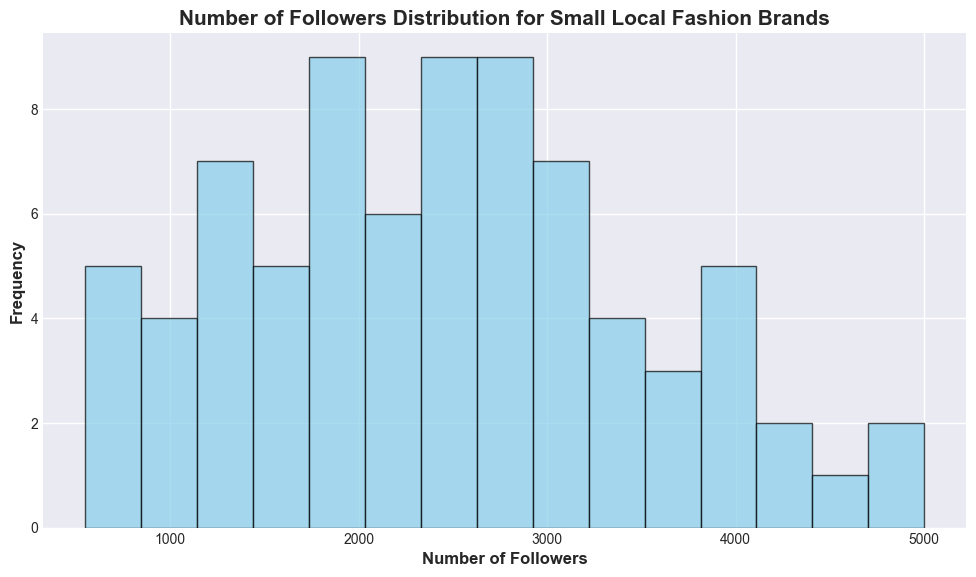What is the most common range of followers? Observe the heights of the bars in the histogram. The tallest bar represents the most frequent range of followers.
Answer: 2000 to 3000 Which range has the least number of brands? Identify the shortest bars in the histogram, which indicate the range with the least frequency.
Answer: 5000 to 6000 Are there more brands with followers between 1000-2000 or 3000-4000? Compare the heights of the bars for the ranges 1000-2000 and 3000-4000.
Answer: 1000-2000 What's the average number of followers for brands in the most common range? First, identify the most common range (2000-3000). Then, calculate the mean number of followers for the brands within this range.
Answer: 2500 How does the distribution skew? Look for the balance of the histogram, especially the frequency of lower vs. higher follower counts.
Answer: Right-skewed Which range has the second-highest frequency? Identify the bar with the second-highest height on the histogram.
Answer: 3000 to 4000 Is there a significant difference between the frequencies of the ranges 1000-2000 and 2000-3000? Compare the heights of the bars within these ranges to determine the difference.
Answer: Yes What is the approximate median number of followers? Find the middle value by identifying the exact or approximate central bar of the histogram.
Answer: 2500 What color is used in the histogram, and what does it signify? Refer to the color coding of the bars in the histogram and identify its purpose.
Answer: Sky blue; signifies frequency How does the frequency distribution of followers look visually? Describe the general shape and spread of the bars in the histogram.
Answer: Clustered around the middle with a right tail 